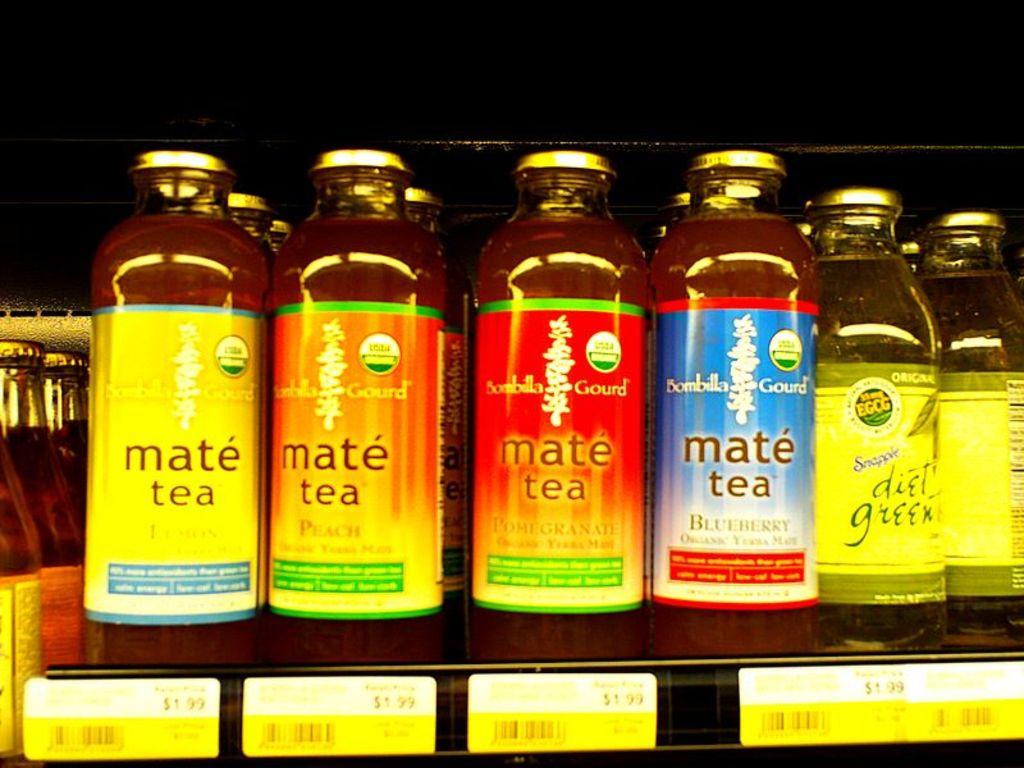What type of beverage is stocked on the shelf?
Make the answer very short. Mate tea. What kind of tea is in the four bottles on the left?
Your response must be concise. Mate tea. 